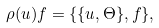<formula> <loc_0><loc_0><loc_500><loc_500>\rho ( u ) f = \{ \{ u , \Theta \} , f \} ,</formula> 